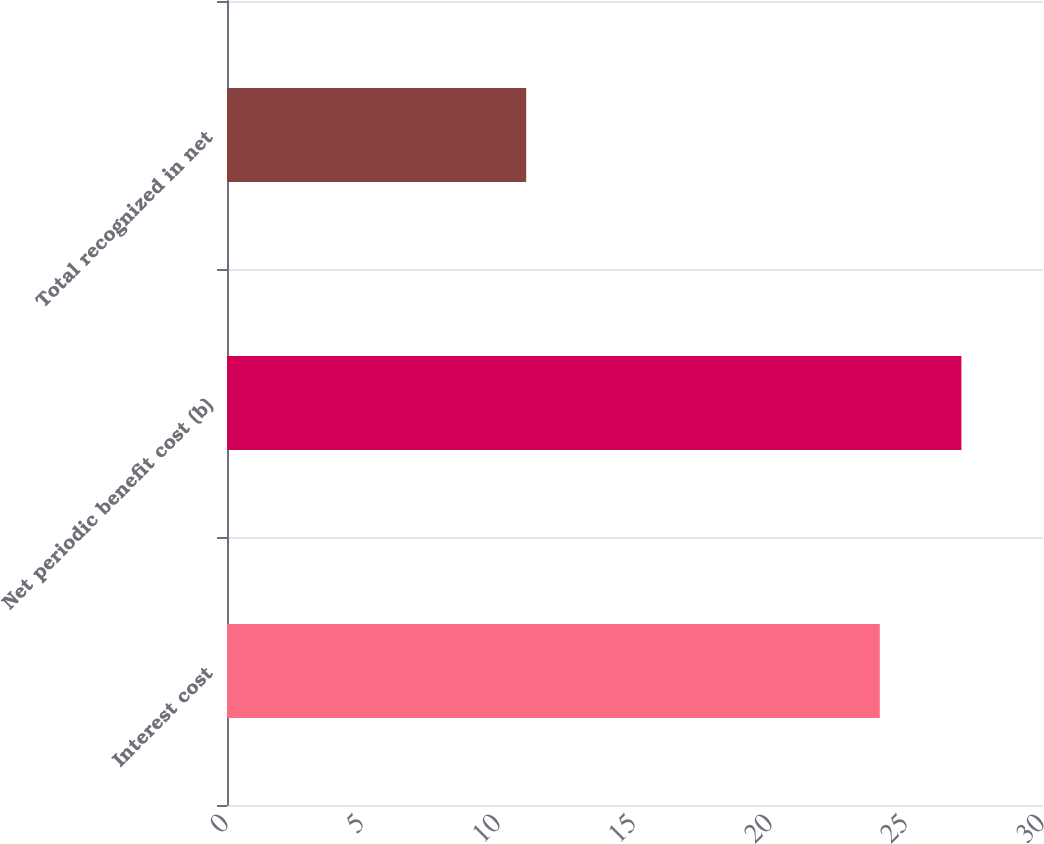<chart> <loc_0><loc_0><loc_500><loc_500><bar_chart><fcel>Interest cost<fcel>Net periodic benefit cost (b)<fcel>Total recognized in net<nl><fcel>24<fcel>27<fcel>11<nl></chart> 